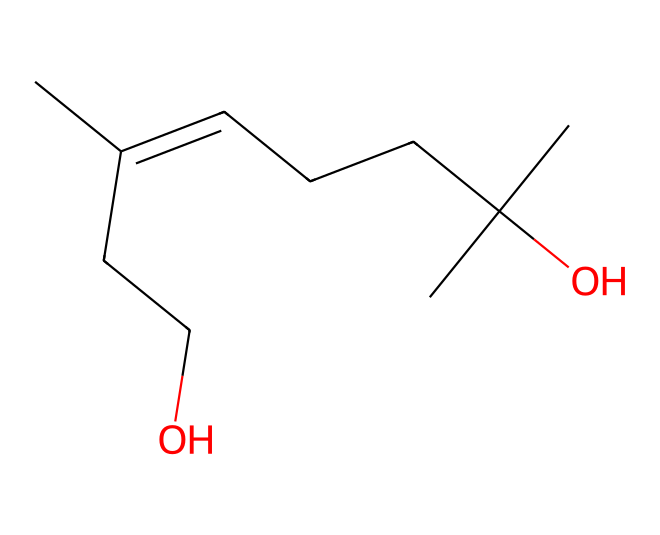what is the function of the alcohol group in this chemical? The alcohol group, indicated by the -OH in the structure, can provide water solubility and act as a mild insect repellent. This helps in making the bug spray safer for frogs while still effective against pests.
Answer: water solubility how many carbon atoms are present in this chemical? By counting the "C" symbols in the SMILES representation, we see that there are 9 carbon atoms in total when considering the branching and the structure.
Answer: 9 does this chemical likely have a sweet or bitter taste? The presence of the alcohol group in this chemical often correlates with a sweeter taste due to the sugar-like nature of alcohols compared to many other compounds which could be bitter.
Answer: sweet what type of functional groups are present in this chemical? The SMILES shows an alcohol group (indicated by -OH) and a long carbon chain which classifies it primarily as an alcohol, a type of organic chemical functional group.
Answer: alcohol is this chemical likely to evaporate quickly or slowly? Given its long carbon chain, which usually corresponds to higher molecular weight, it is likely to evaporate slowly compared to simple alcohols or lighter compounds, reducing its impact on non-target organisms like frogs.
Answer: slowly 